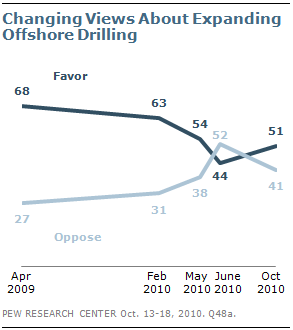Identify some key points in this picture. The difference between favor and oppose graphs is decreasing from April 2009 to May 2010, as indicated by the response "Yes. The color of the oppose line is lighter than the favor line, indicating a higher level of opposition. 